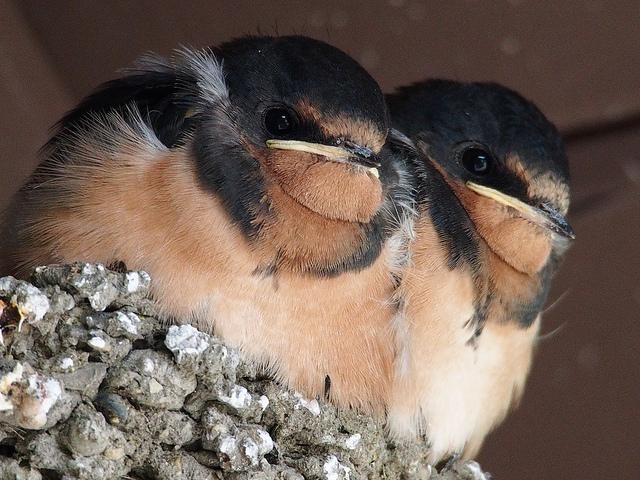How many are there?
Write a very short answer. 2. What color are the birds eyes?
Write a very short answer. Black. What color is the animal?
Quick response, please. Tan. How many animals are shown?
Answer briefly. 2. What kind of animals are these?
Concise answer only. Birds. 